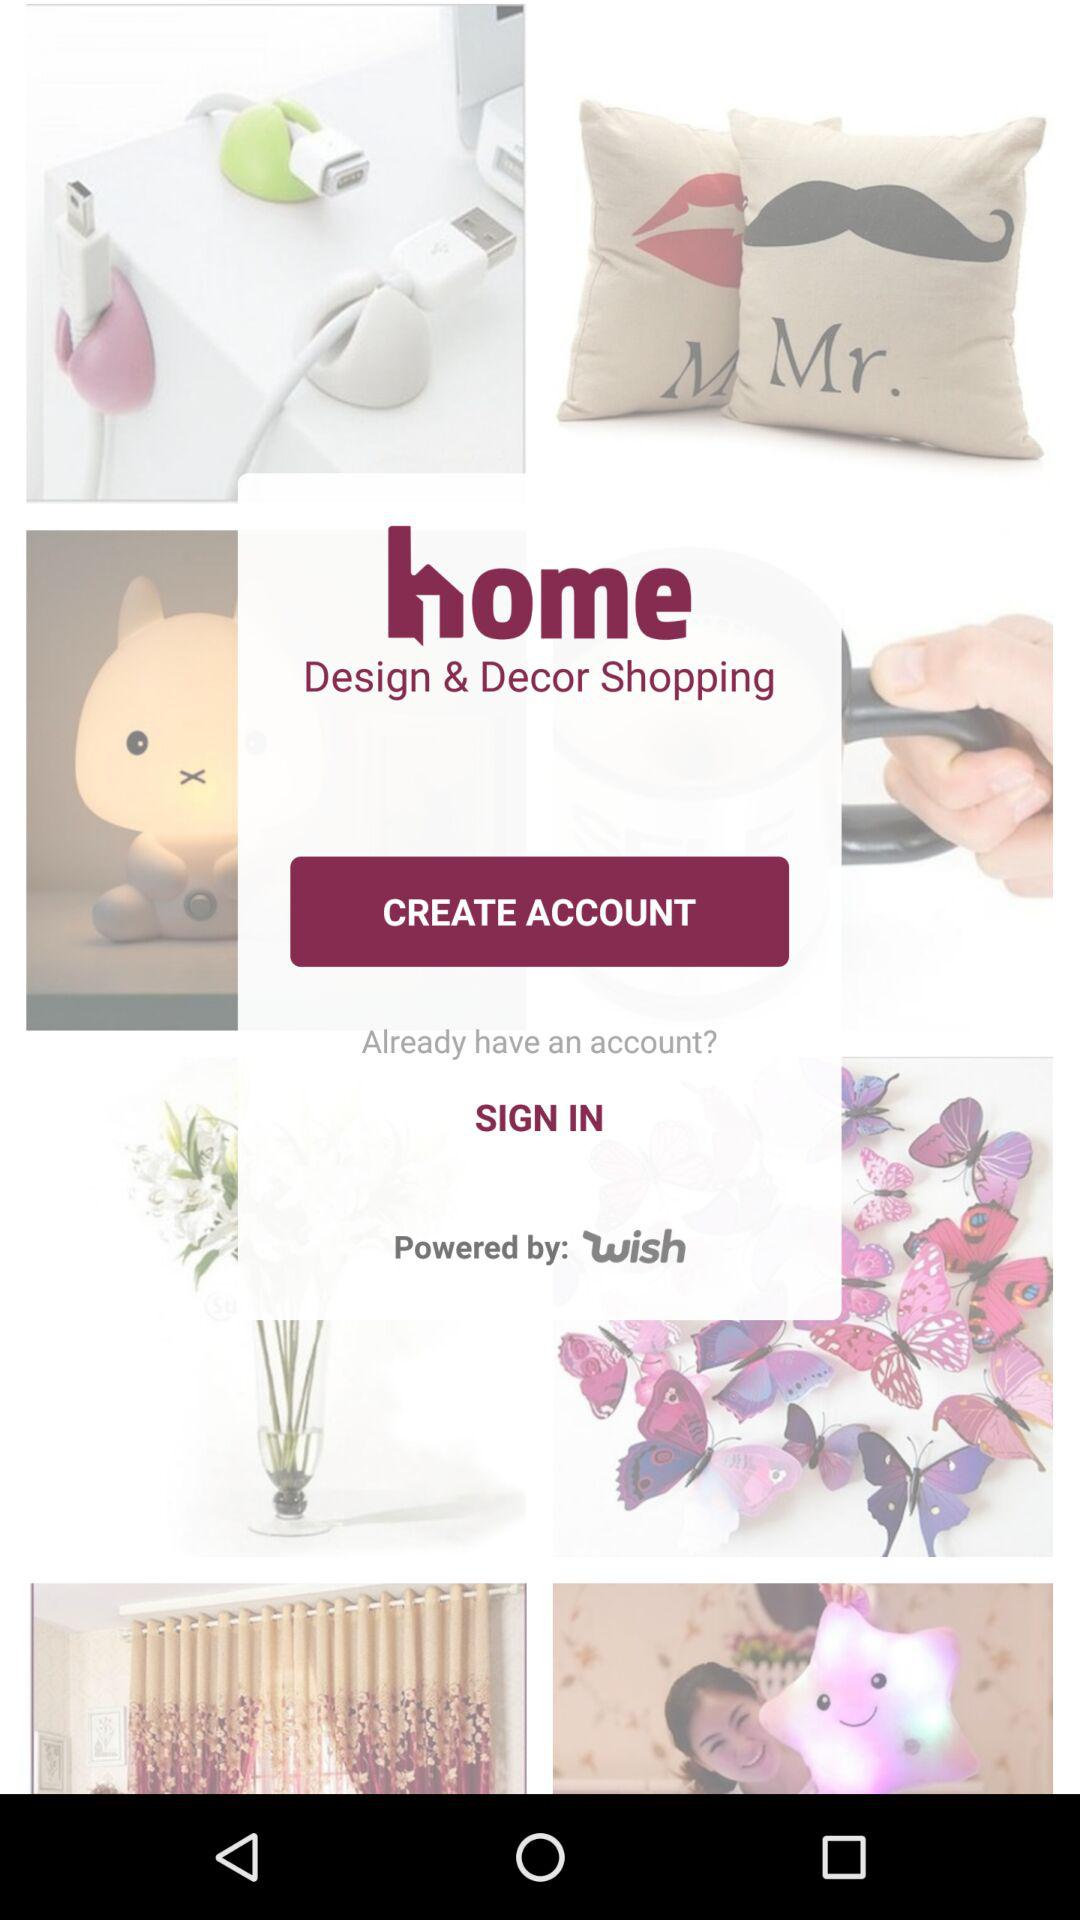It is powered by whom? It is powered by "wish". 